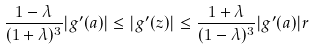Convert formula to latex. <formula><loc_0><loc_0><loc_500><loc_500>\frac { 1 - \lambda } { ( 1 + \lambda ) ^ { 3 } } | g ^ { \prime } ( a ) | \leq | g ^ { \prime } ( z ) | \leq \frac { 1 + \lambda } { ( 1 - \lambda ) ^ { 3 } } | g ^ { \prime } ( a ) | r</formula> 